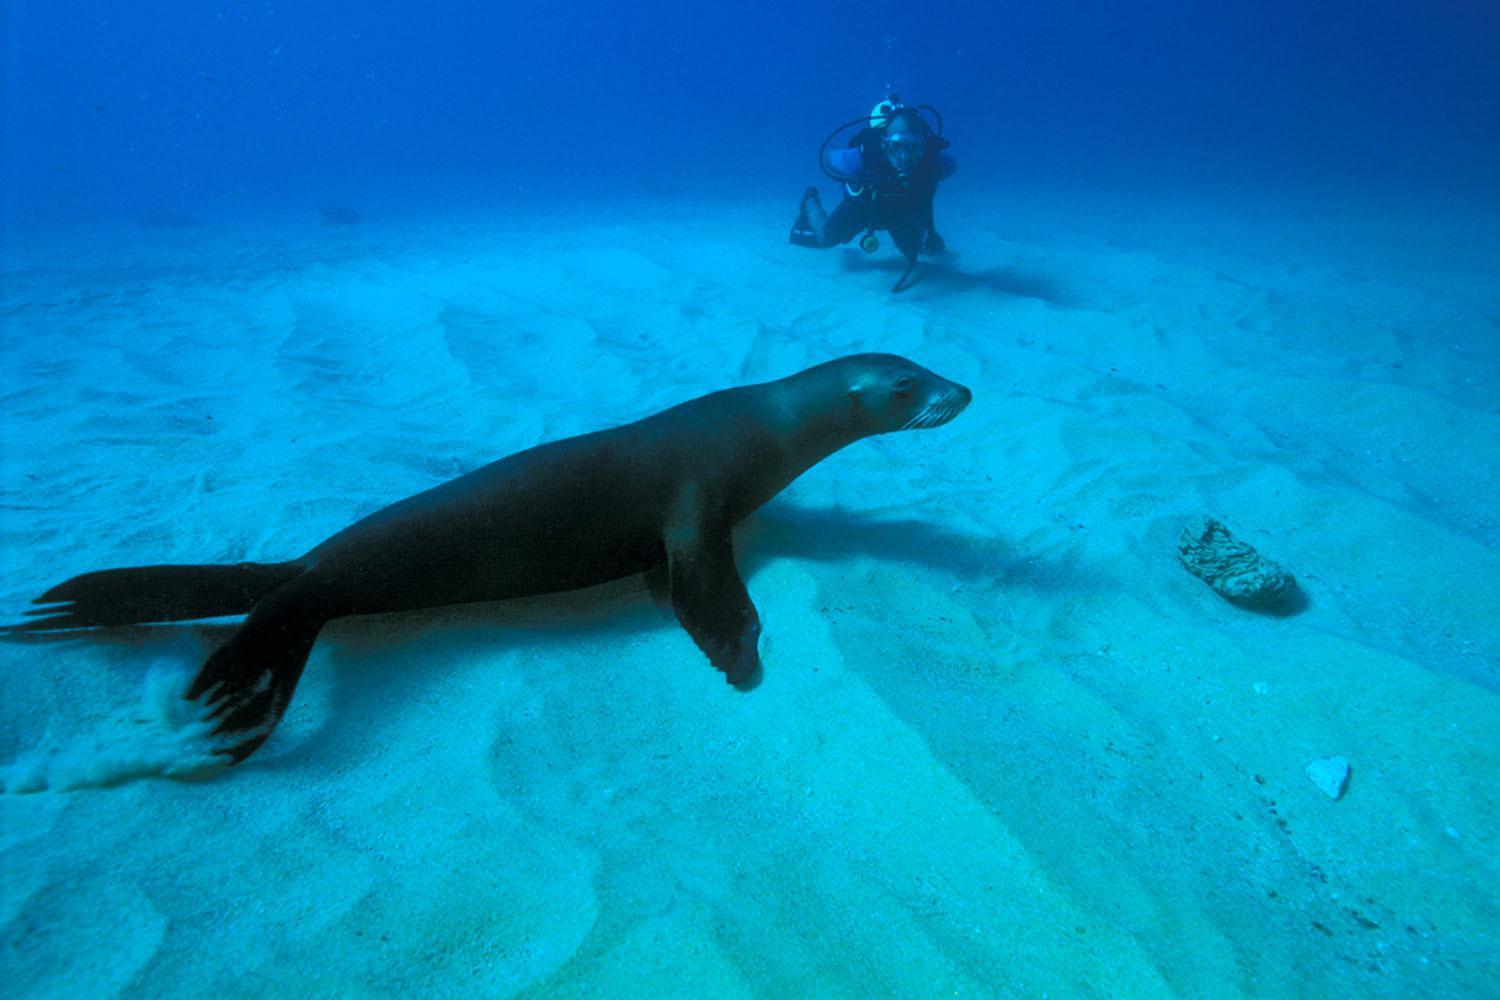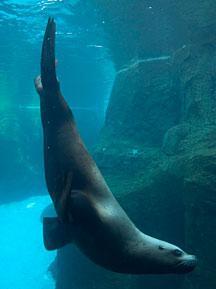The first image is the image on the left, the second image is the image on the right. Considering the images on both sides, is "There is one person on the ocean floor." valid? Answer yes or no. Yes. The first image is the image on the left, the second image is the image on the right. For the images displayed, is the sentence "there is a diver looking at a seal underwater" factually correct? Answer yes or no. Yes. 